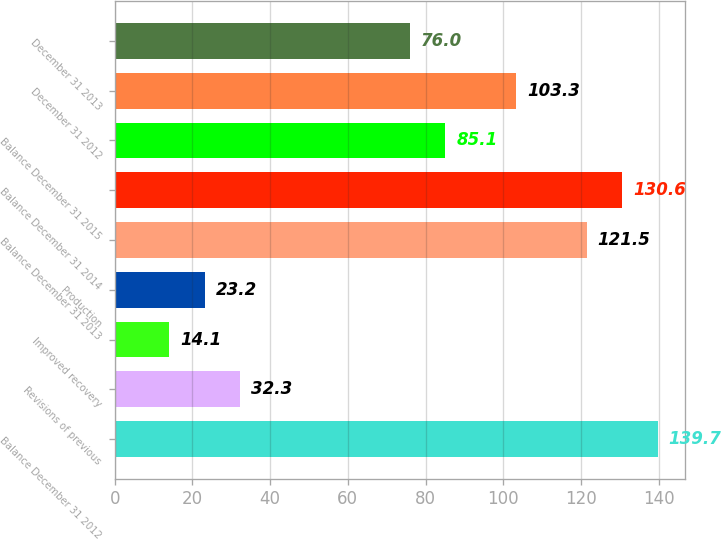Convert chart. <chart><loc_0><loc_0><loc_500><loc_500><bar_chart><fcel>Balance December 31 2012<fcel>Revisions of previous<fcel>Improved recovery<fcel>Production<fcel>Balance December 31 2013<fcel>Balance December 31 2014<fcel>Balance December 31 2015<fcel>December 31 2012<fcel>December 31 2013<nl><fcel>139.7<fcel>32.3<fcel>14.1<fcel>23.2<fcel>121.5<fcel>130.6<fcel>85.1<fcel>103.3<fcel>76<nl></chart> 